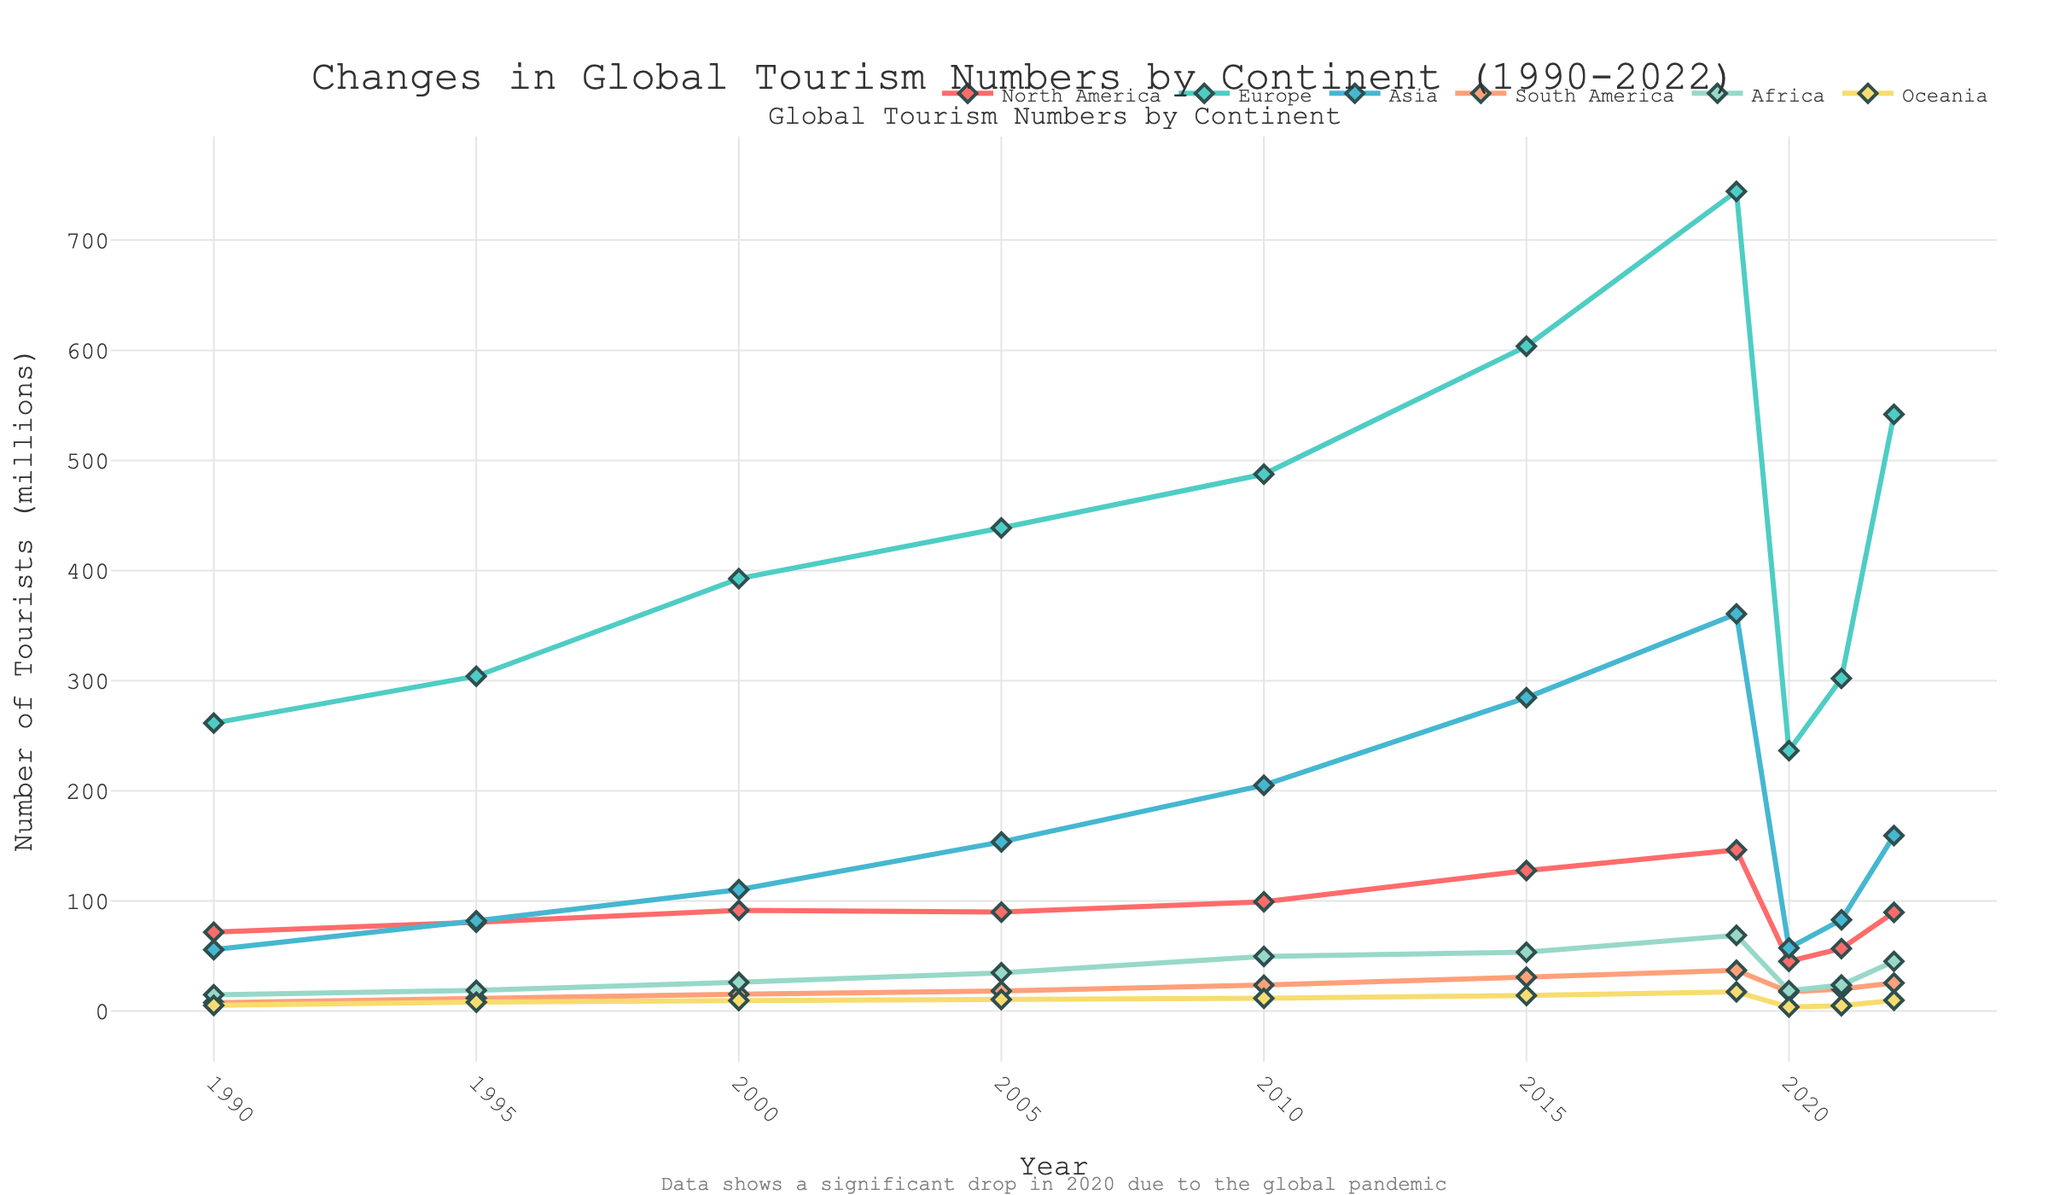What is the overall trend of tourism numbers in Europe from 1990 to 2019? The number of tourists in Europe shows a consistent upward trend from 261.5 million in 1990 to 744.3 million in 2019, showing steady growth over the years.
Answer: Upward trend Which continent experienced the most significant drop in tourism numbers from 2019 to 2020? Comparing the data points for 2019 and 2020, North America experienced the sharpest decline, dropping from 146.4 million to 45.2 million tourists.
Answer: North America What is the numerical difference in tourism numbers between Asia and Europe in 2021? In 2021, Europe had 302.1 million tourists, and Asia had 82.9 million. The difference is 302.1 - 82.9 = 219.2 million.
Answer: 219.2 million Between which two consecutive years did Africa see the highest growth in tourism? By comparing year-on-year differences, Africa saw the highest growth from 2000 to 2005, increasing from 26.2 million to 34.8 million, which is a difference of 8.6 million.
Answer: 2000 to 2005 What is the average number of tourists in Oceania from 1990 to 2019? Adding the tourist numbers for Oceania from 1990 to 2019: 5.2 + 8.1 + 9.6 + 10.5 + 11.6 + 14.2 + 17.5, we get 76.7 million. The average is 76.7 / 7 = 10.96 million.
Answer: 10.96 million How did the tourism numbers in South America change from 1995 to 2022? In 1995, South America had 11.7 million tourists, which increased to 25.6 million in 2022. The overall change is 25.6 - 11.7 = 13.9 million, showing an increase over the period.
Answer: Increased by 13.9 million Visually, which two continents appear to have closely aligned trends from 2010 onwards? Examining the visual trend lines from 2010 onwards, South America and Oceania show relatively similar patterns with modest growth and a drop in 2020.
Answer: South America and Oceania Which time period shows the most significant impact of the global pandemic on global tourism numbers? The most striking global decline in tourism numbers is between 2019 and 2020, indicated by the sharp drop across all continents.
Answer: 2019 to 2020 What is the ratio of tourists in North America to Europe in 2022? In 2022, North America had 89.7 million tourists, and Europe had 541.8 million. The ratio is 89.7 / 541.8 ≈ 0.1655.
Answer: 0.1655 